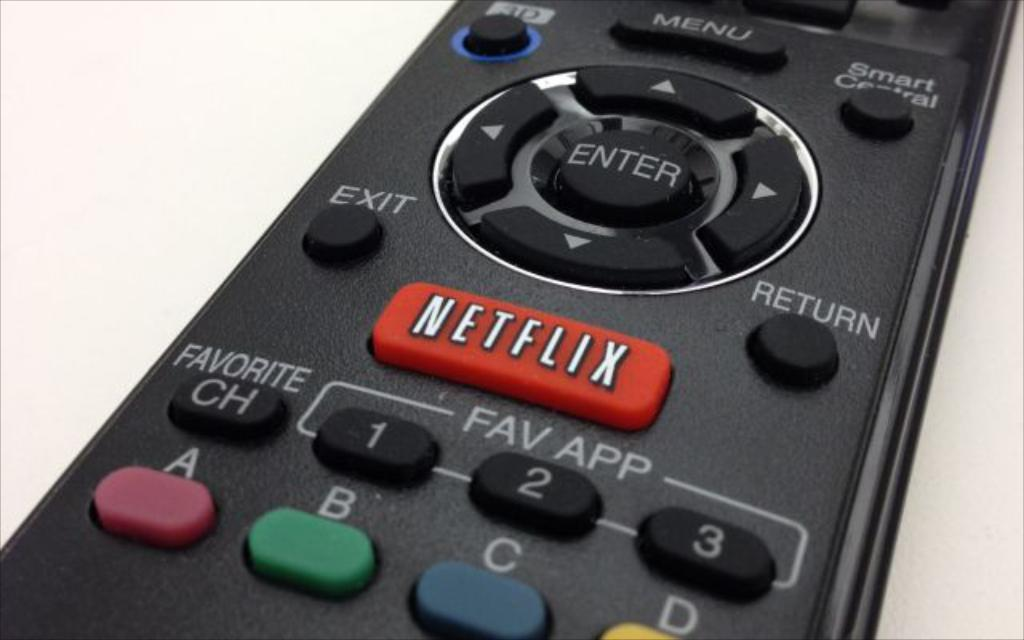<image>
Give a short and clear explanation of the subsequent image. A remote control shows different buttons including a red one for NETFLIX. 